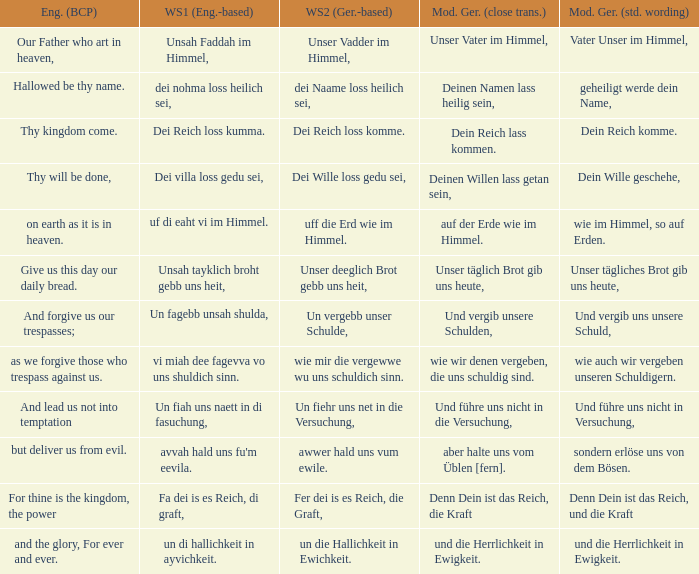What is the english (bcp) phrase "for thine is the kingdom, the power" in modern german with standard wording? Denn Dein ist das Reich, und die Kraft. 